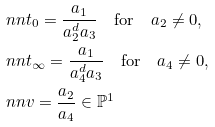<formula> <loc_0><loc_0><loc_500><loc_500>& \ n n t _ { 0 } = \frac { a _ { 1 } } { a _ { 2 } ^ { d } a _ { 3 } } \quad \text {for} \quad a _ { 2 } \neq 0 , \\ & \ n n t _ { \infty } = \frac { a _ { 1 } } { a _ { 4 } ^ { d } a _ { 3 } } \quad \text {for} \quad a _ { 4 } \neq 0 , \\ & \ n n v = \frac { a _ { 2 } } { a _ { 4 } } \in \mathbb { P } ^ { 1 }</formula> 